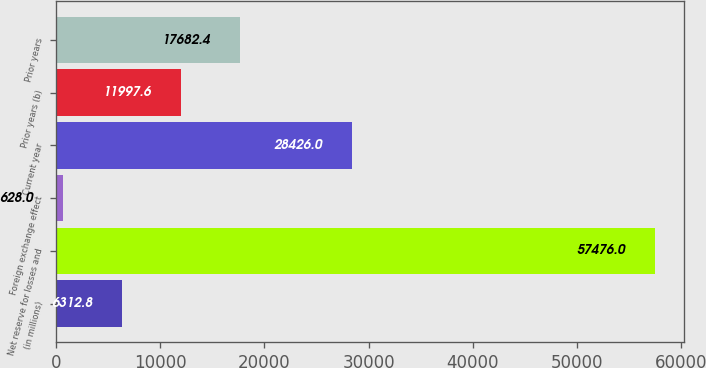<chart> <loc_0><loc_0><loc_500><loc_500><bar_chart><fcel>(in millions)<fcel>Net reserve for losses and<fcel>Foreign exchange effect<fcel>Current year<fcel>Prior years (b)<fcel>Prior years<nl><fcel>6312.8<fcel>57476<fcel>628<fcel>28426<fcel>11997.6<fcel>17682.4<nl></chart> 